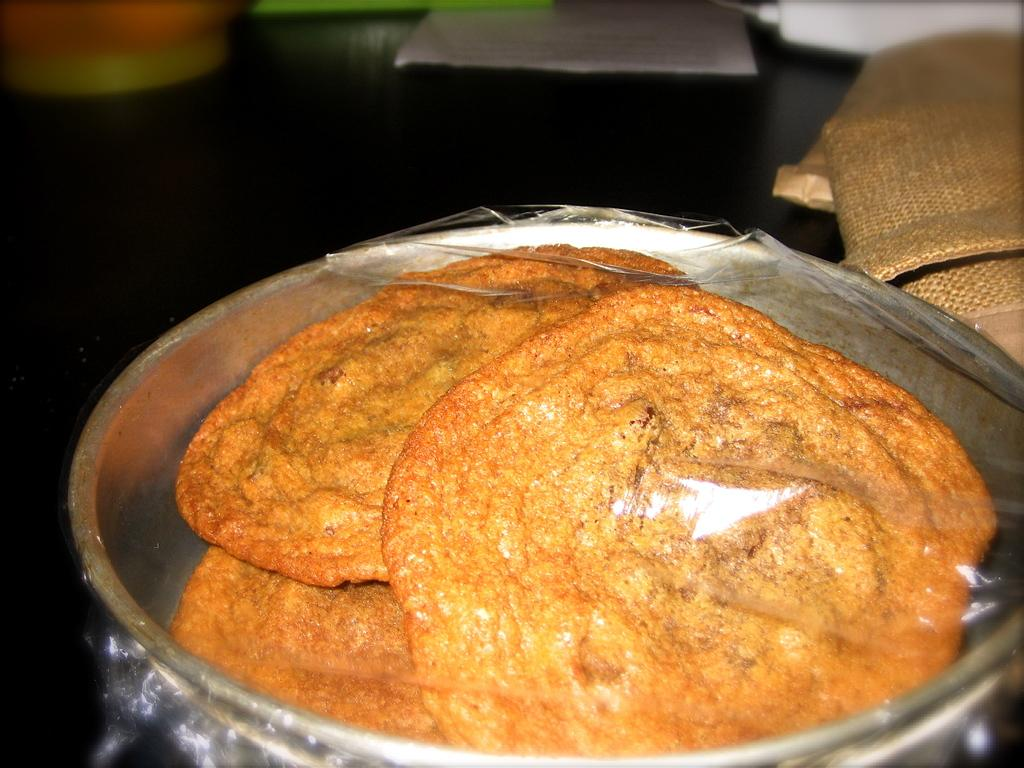What is the main object in the image? There is a table in the image. What is placed on the table? There is paper and a polythene bag on the table. What else can be seen on the table? There is food placed in an utensil on the table. What type of caption is written on the paper in the image? There is no caption written on the paper in the image; it is just a plain piece of paper. Can you see a stick on the table in the image? There is no stick present on the table in the image. 